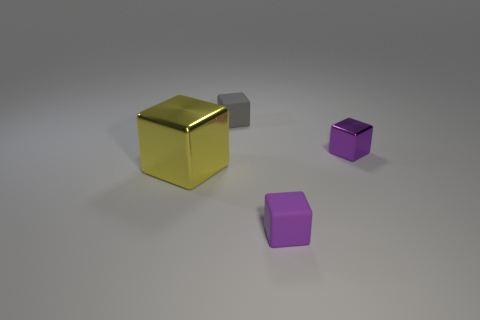Subtract all purple blocks. How many were subtracted if there are1purple blocks left? 1 Subtract all purple blocks. How many blocks are left? 2 Subtract all big shiny cubes. How many cubes are left? 3 Add 1 gray things. How many objects exist? 5 Subtract 2 cubes. How many cubes are left? 2 Subtract all yellow cubes. Subtract all brown cylinders. How many cubes are left? 3 Subtract all purple spheres. How many yellow cubes are left? 1 Subtract all big purple matte cubes. Subtract all yellow cubes. How many objects are left? 3 Add 3 shiny cubes. How many shiny cubes are left? 5 Add 2 large brown cubes. How many large brown cubes exist? 2 